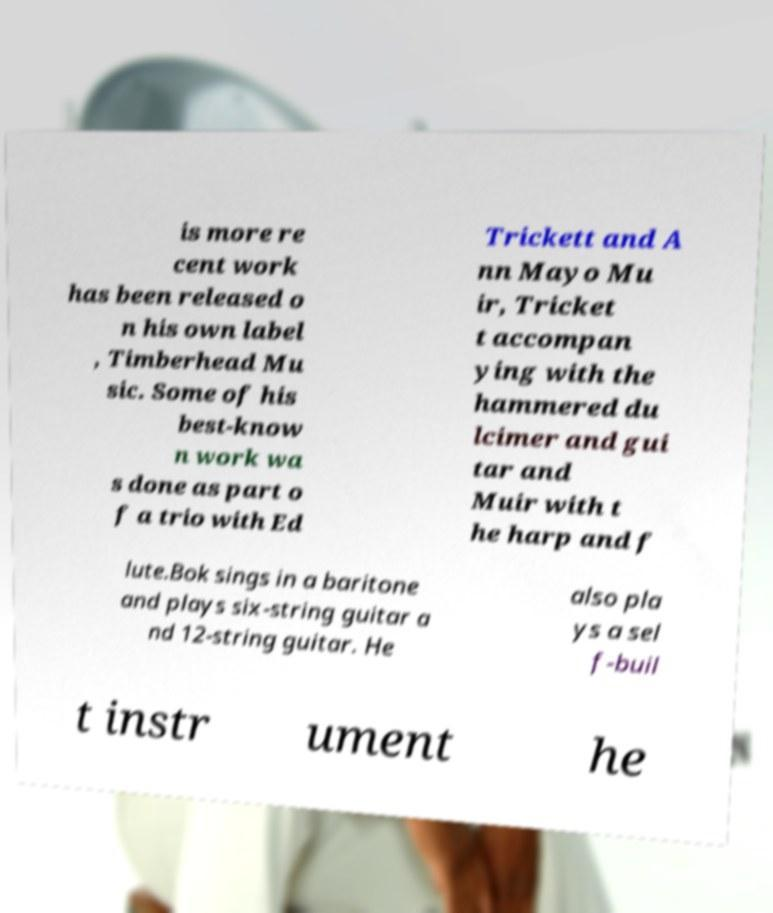Can you read and provide the text displayed in the image?This photo seems to have some interesting text. Can you extract and type it out for me? is more re cent work has been released o n his own label , Timberhead Mu sic. Some of his best-know n work wa s done as part o f a trio with Ed Trickett and A nn Mayo Mu ir, Tricket t accompan ying with the hammered du lcimer and gui tar and Muir with t he harp and f lute.Bok sings in a baritone and plays six-string guitar a nd 12-string guitar. He also pla ys a sel f-buil t instr ument he 